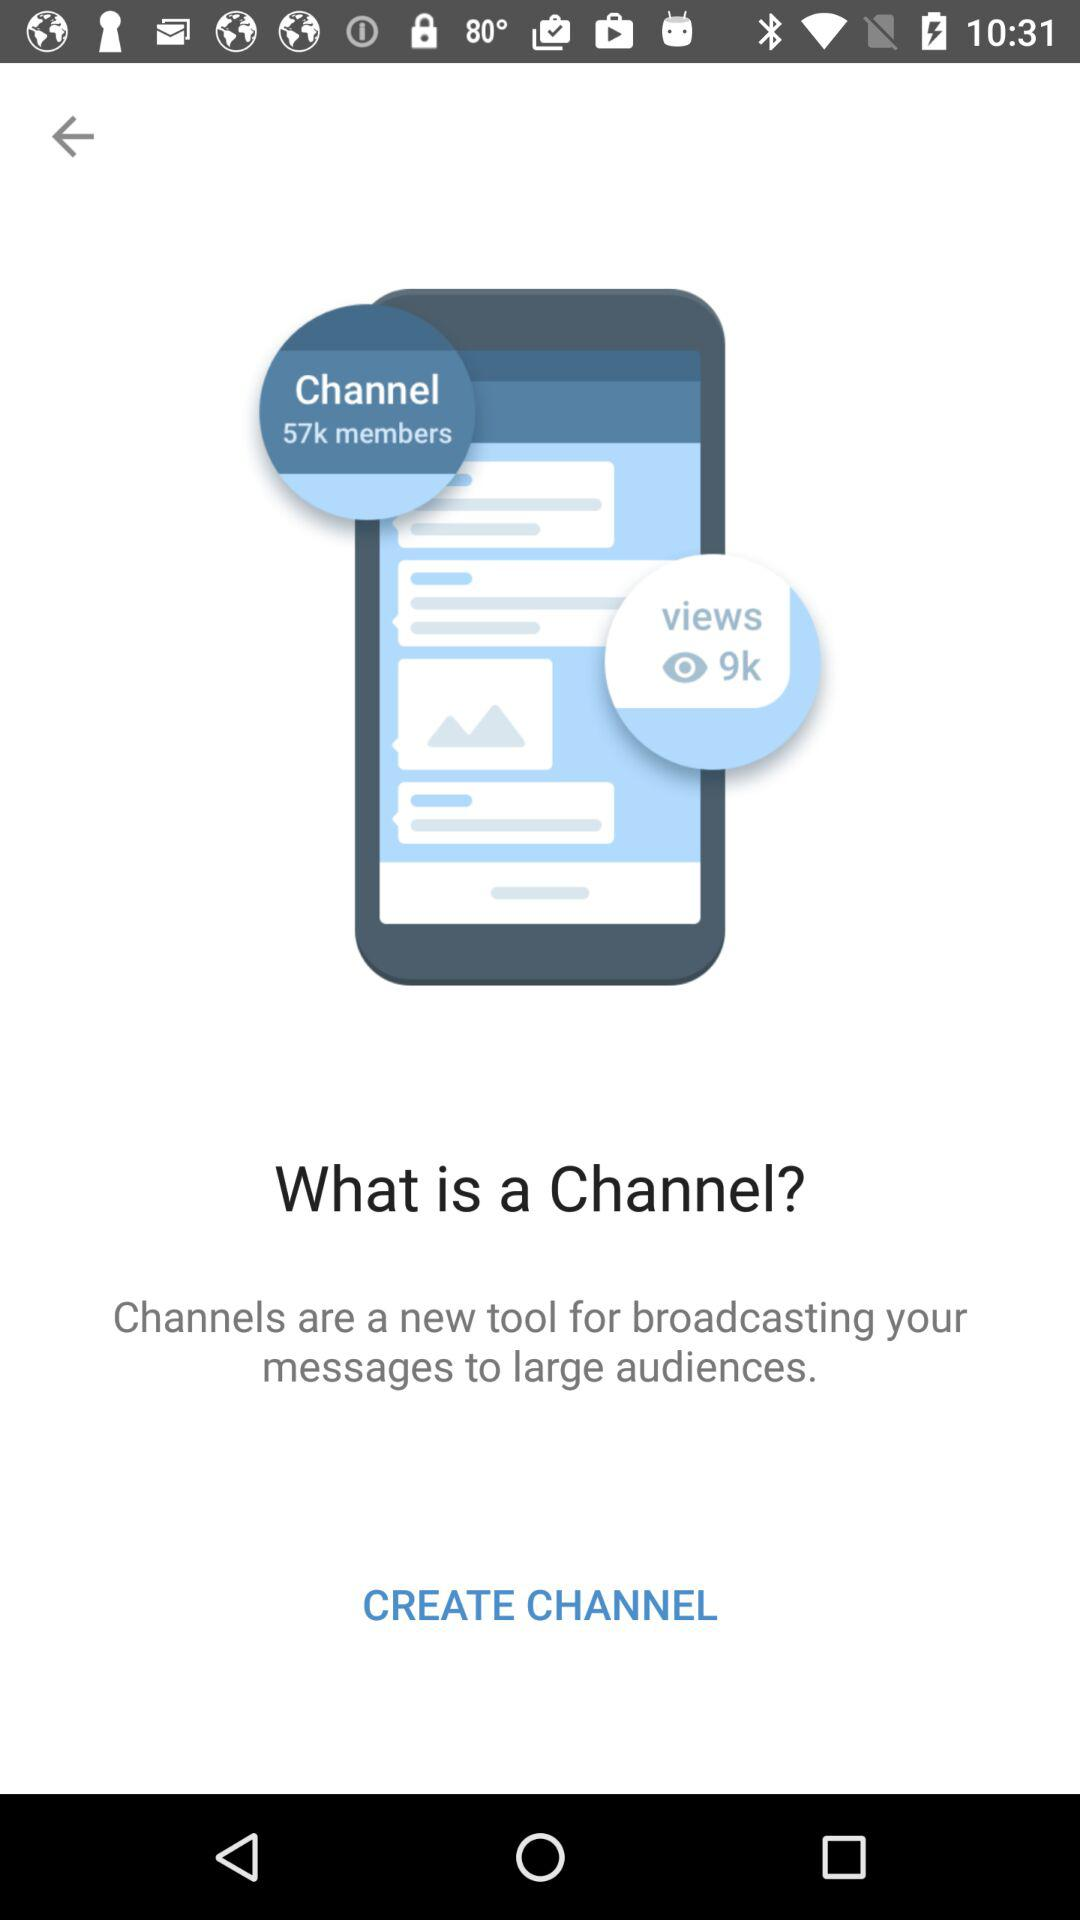How many members are there? There are 57k members. 